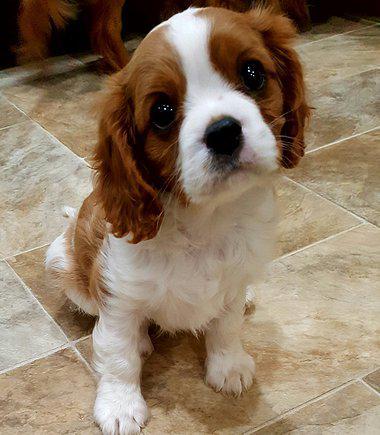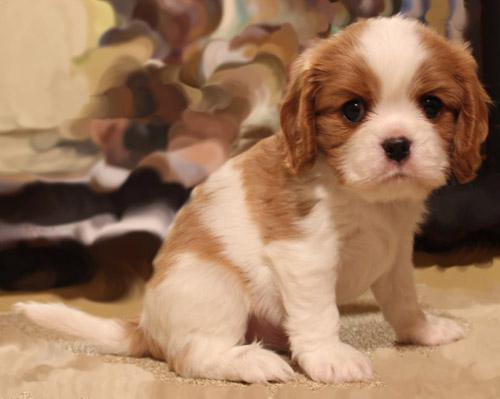The first image is the image on the left, the second image is the image on the right. Examine the images to the left and right. Is the description "There are exactly two animals in the image on the left." accurate? Answer yes or no. No. The first image is the image on the left, the second image is the image on the right. For the images shown, is this caption "An image shows one brown and white dog posed on a brownish tile floor." true? Answer yes or no. Yes. The first image is the image on the left, the second image is the image on the right. Analyze the images presented: Is the assertion "An image shows two furry animals side-by-side." valid? Answer yes or no. No. 